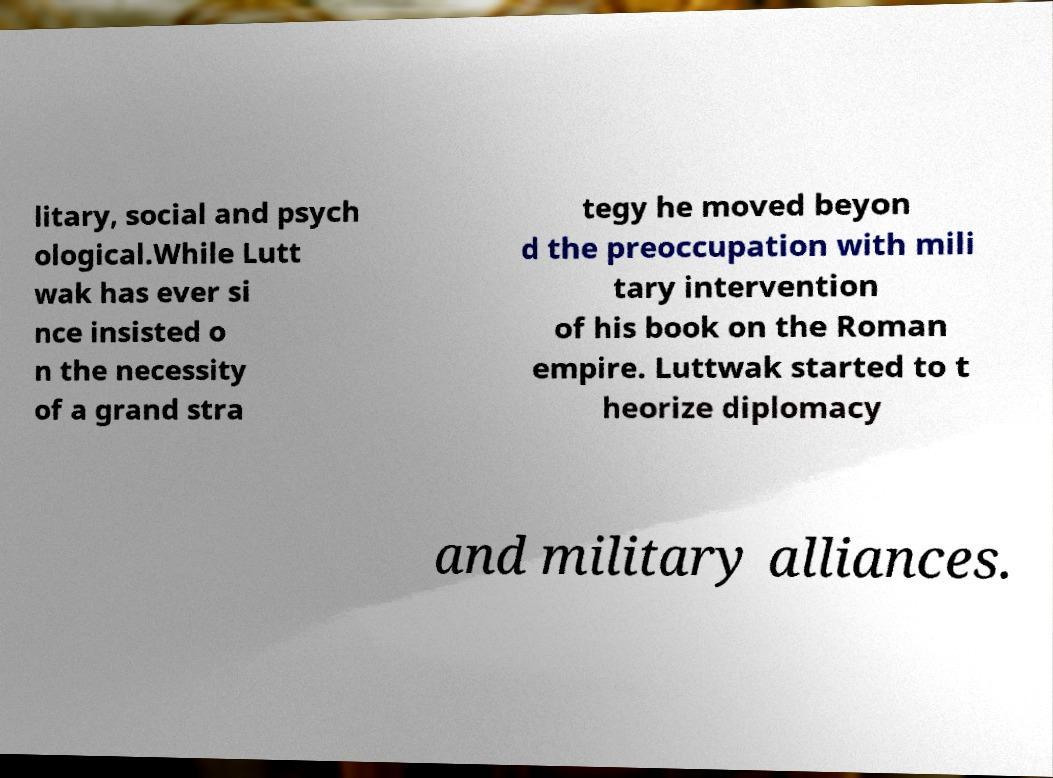Could you assist in decoding the text presented in this image and type it out clearly? litary, social and psych ological.While Lutt wak has ever si nce insisted o n the necessity of a grand stra tegy he moved beyon d the preoccupation with mili tary intervention of his book on the Roman empire. Luttwak started to t heorize diplomacy and military alliances. 